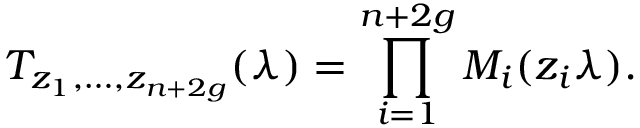Convert formula to latex. <formula><loc_0><loc_0><loc_500><loc_500>T _ { z _ { 1 } , \dots , z _ { n + 2 g } } ( \lambda ) = \prod _ { i = 1 } ^ { n + 2 g } { M _ { i } ( z _ { i } \lambda ) } .</formula> 